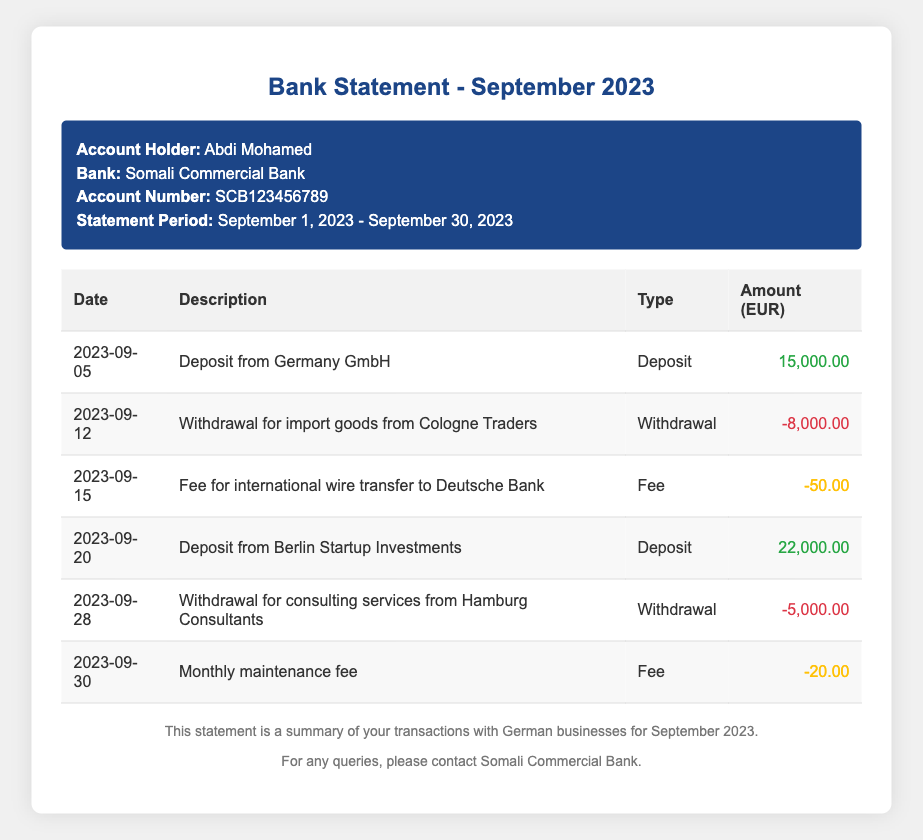What is the total amount deposited from German businesses? The total amount deposited is the sum of deposits listed in the document, which is 15,000.00 + 22,000.00 = 37,000.00.
Answer: 37,000.00 What was the fee for the international wire transfer? There is a specific fee listed for an international wire transfer, which is presented in the document.
Answer: 50.00 How many withdrawals were made during September 2023? The document lists three withdrawals made during the month, shown in the transactions.
Answer: 3 What was the date of the last transaction? The last transaction in the document is dated, providing a concrete end to the transactions listed.
Answer: 2023-09-30 What is the account holder's name? The account holder's name is explicitly mentioned in the header section of the document.
Answer: Abdi Mohamed What type of transaction occurred on September 12, 2023? The document specifies the type of transaction that took place on this date, detailing its nature as published.
Answer: Withdrawal Which company made the first deposit? The company that made the first deposit is clearly stated in the transaction details for the corresponding date.
Answer: Germany GmbH What is the total number of transaction types listed in the statement? The document categorizes transactions into types, providing a count of their occurrence in that month.
Answer: 6 What is the total amount of monthly maintenance fee? The document clearly specifies the amount allocated for the monthly maintenance fee, listed under fees.
Answer: 20.00 